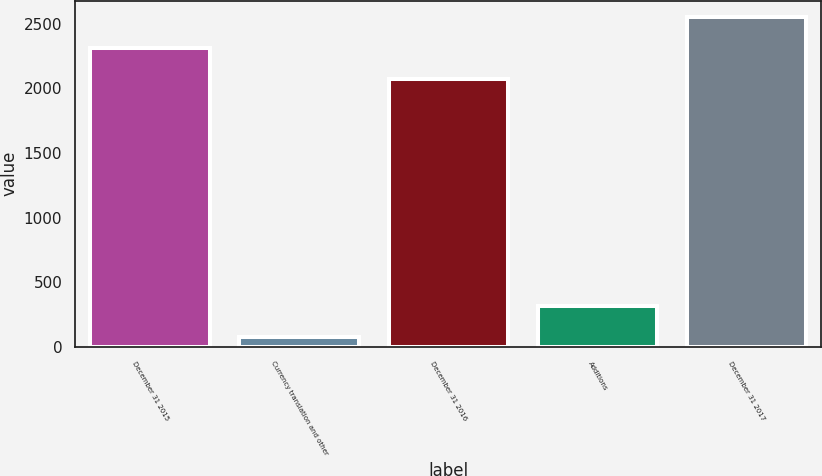<chart> <loc_0><loc_0><loc_500><loc_500><bar_chart><fcel>December 31 2015<fcel>Currency translation and other<fcel>December 31 2016<fcel>Additions<fcel>December 31 2017<nl><fcel>2310.8<fcel>76<fcel>2071<fcel>315.8<fcel>2550.6<nl></chart> 